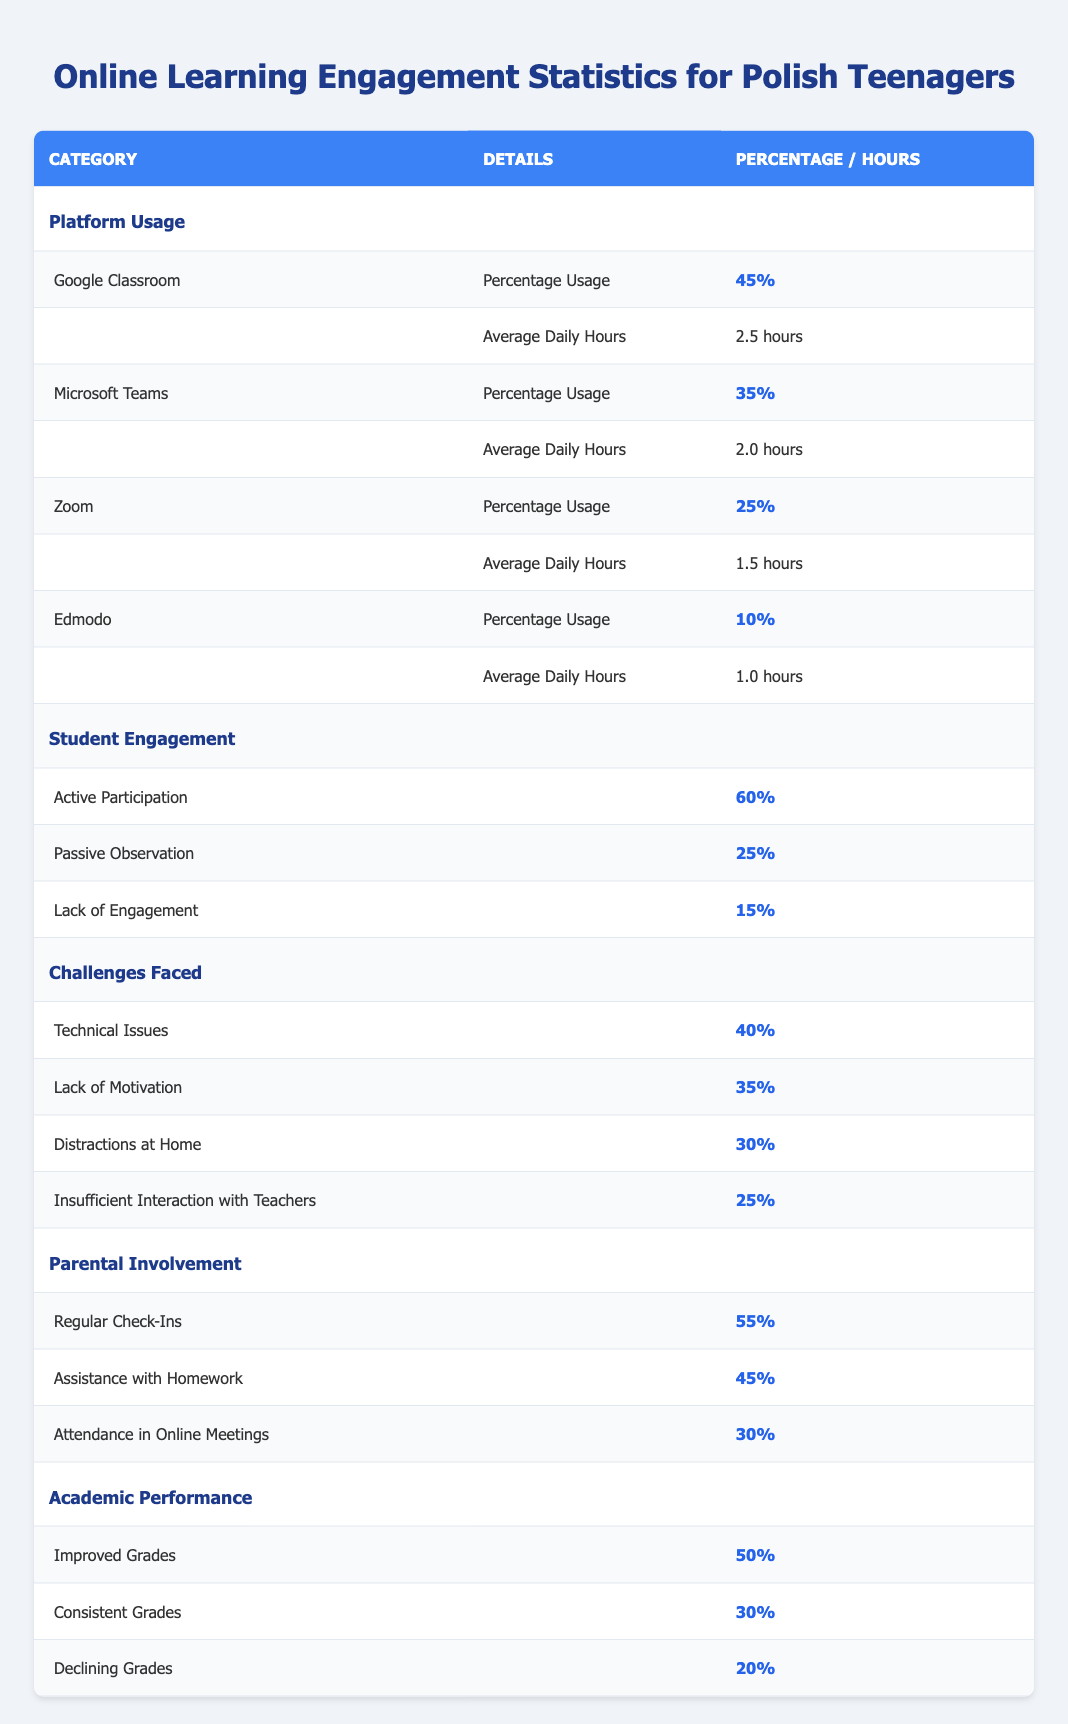What platform has the highest usage among Polish teenagers for online learning? Google Classroom is listed with a percentage usage of 45%, which is higher than the other platforms.
Answer: Google Classroom How many hours do students spend on average using Microsoft Teams daily? The table shows that students spend an average of 2.0 hours daily on Microsoft Teams.
Answer: 2.0 hours What percentage of students are actively participating in online learning? The table indicates that 60% of students are engaged in active participation, which is the highest engagement type mentioned.
Answer: 60% What percentage of teenagers face technical issues as a challenge in online learning? The table specifies that 40% of teenagers are affected by technical issues.
Answer: 40% How many teenagers lack motivation in their studies? 35% of teenagers are affected by a lack of motivation according to the table data.
Answer: 35% Is the percentage of improved grades higher than that of declining grades? Yes, improved grades at 50% are higher than the 20% of teenagers with declining grades.
Answer: Yes What is the difference in percentage between students facing distractions at home and those facing insufficient interaction with teachers? Distractions at home affect 30% of students, while insufficient interaction with teachers affects 25%. The difference is 30% - 25% = 5%.
Answer: 5% What is the total percentage of parental involvement types listed in the table? The total percentage of parental involvement can be calculated as 55% (Regular Check-Ins) + 45% (Assistance with Homework) + 30% (Attendance in Online Meetings) = 130%.
Answer: 130% If we consider the lack of engagement type, what percentage of students are engaged either actively or passively? Active participation is 60% and passive observation is 25%. Together they sum to 60% + 25% = 85%.
Answer: 85% Considering all platforms, what is the average daily usage hours across the listed platforms? The average daily hours can be calculated as follows: (2.5 + 2.0 + 1.5 + 1.0) / 4 = 1.75 hours.
Answer: 1.75 hours 